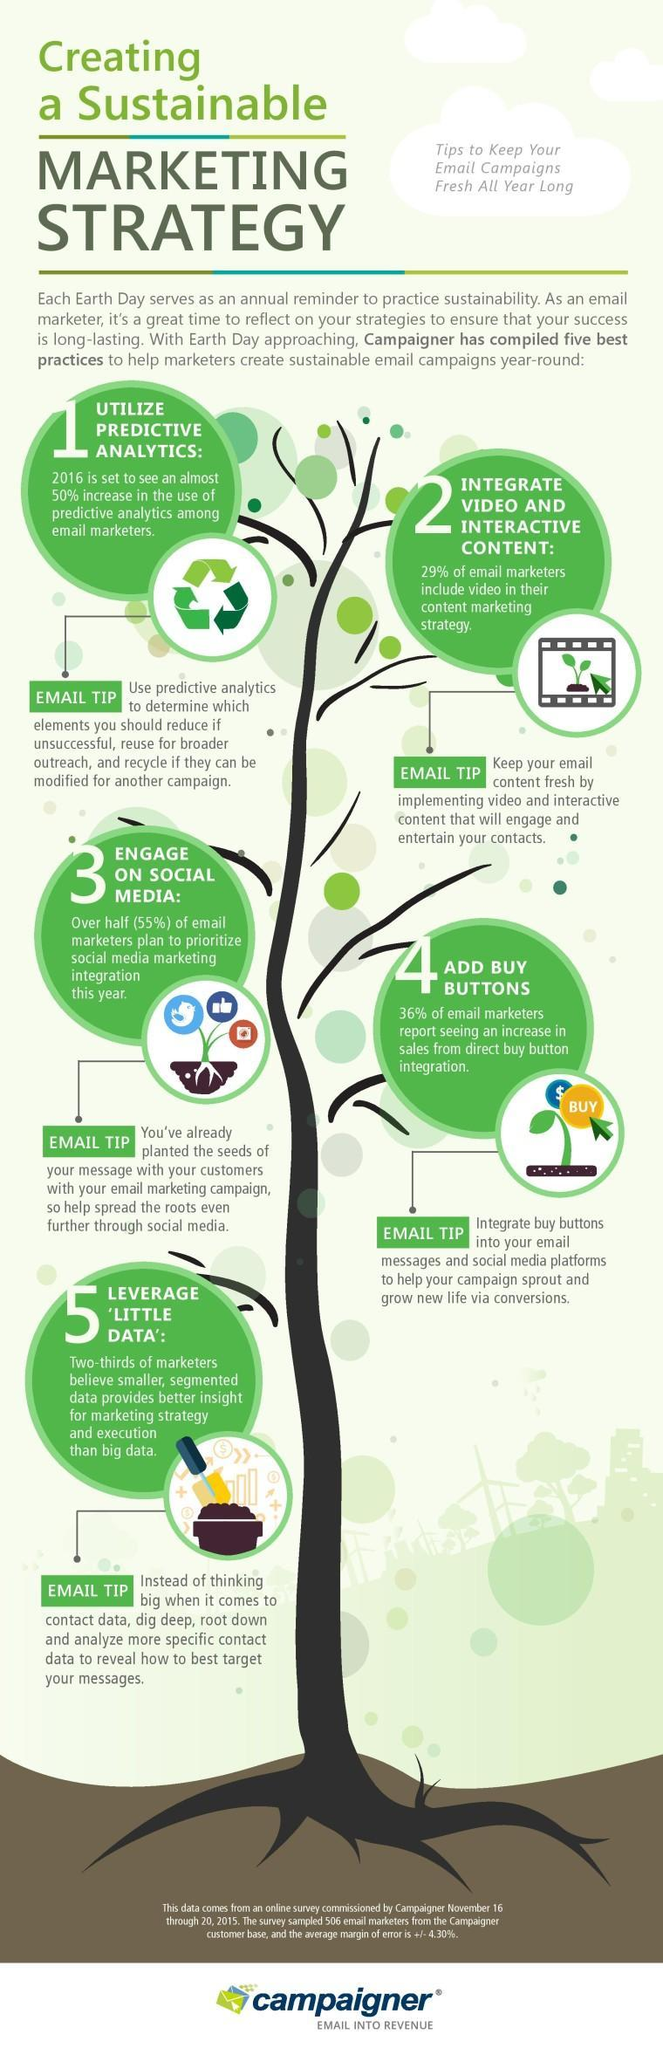Which strategy is sure to boost sales, predictive analysis, buy buttons, or video and interactive content?
Answer the question with a short phrase. buy buttons 